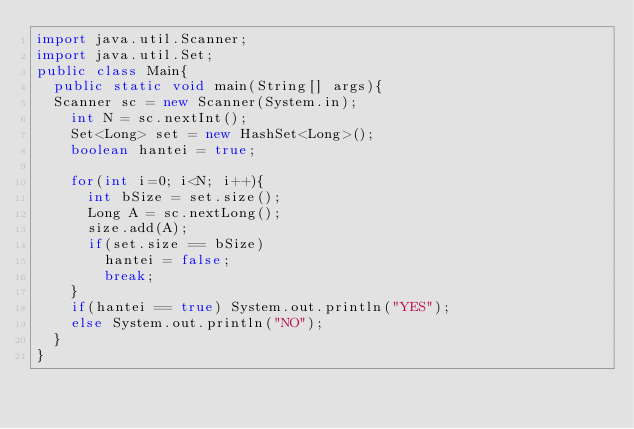<code> <loc_0><loc_0><loc_500><loc_500><_Java_>import java.util.Scanner;
import java.util.Set;
public class Main{
  public static void main(String[] args){
	Scanner sc = new Scanner(System.in);
    int N = sc.nextInt();
    Set<Long> set = new HashSet<Long>();
    boolean hantei = true;
    
    for(int i=0; i<N; i++){
      int bSize = set.size();
      Long A = sc.nextLong();
      size.add(A);
      if(set.size == bSize)
        hantei = false;
        break;
    }
    if(hantei == true) System.out.println("YES");
    else System.out.println("NO");
  }
}
</code> 